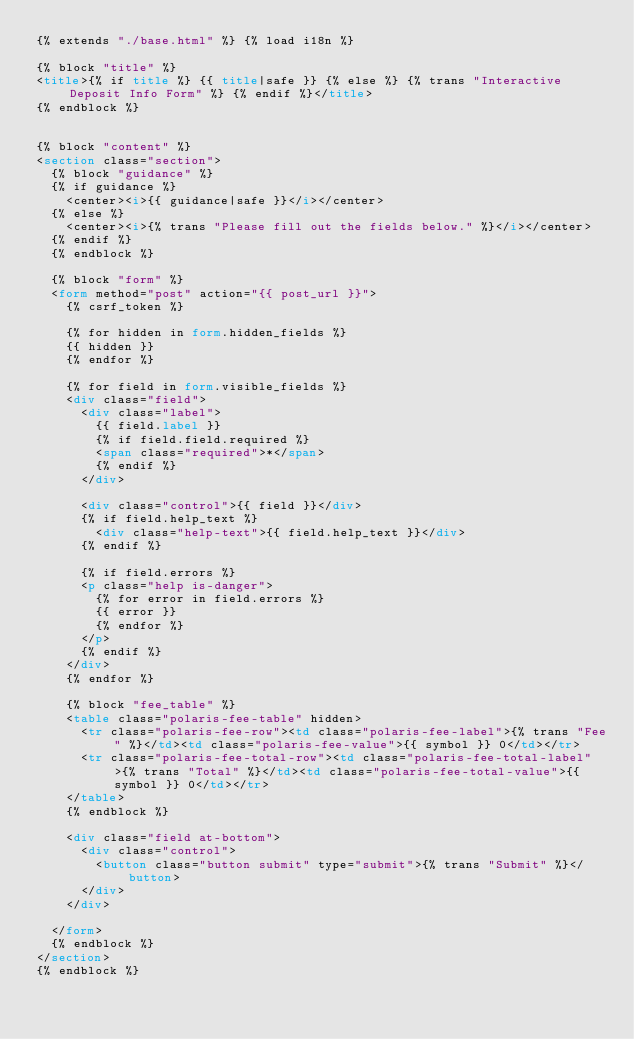<code> <loc_0><loc_0><loc_500><loc_500><_HTML_>{% extends "./base.html" %} {% load i18n %}

{% block "title" %}
<title>{% if title %} {{ title|safe }} {% else %} {% trans "Interactive Deposit Info Form" %} {% endif %}</title>
{% endblock %}


{% block "content" %}
<section class="section">
  {% block "guidance" %}
  {% if guidance %}
    <center><i>{{ guidance|safe }}</i></center>
  {% else %}
    <center><i>{% trans "Please fill out the fields below." %}</i></center>
  {% endif %}
  {% endblock %}

  {% block "form" %}
  <form method="post" action="{{ post_url }}">
    {% csrf_token %}

    {% for hidden in form.hidden_fields %}
    {{ hidden }}
    {% endfor %}

    {% for field in form.visible_fields %}
    <div class="field">
      <div class="label">
        {{ field.label }}
        {% if field.field.required %}
        <span class="required">*</span>
        {% endif %}
      </div>

      <div class="control">{{ field }}</div>
      {% if field.help_text %}
        <div class="help-text">{{ field.help_text }}</div>
      {% endif %}

      {% if field.errors %}
      <p class="help is-danger">
        {% for error in field.errors %}
        {{ error }}
        {% endfor %}
      </p>
      {% endif %}
    </div>
    {% endfor %}

    {% block "fee_table" %}
    <table class="polaris-fee-table" hidden>
      <tr class="polaris-fee-row"><td class="polaris-fee-label">{% trans "Fee" %}</td><td class="polaris-fee-value">{{ symbol }} 0</td></tr>
      <tr class="polaris-fee-total-row"><td class="polaris-fee-total-label">{% trans "Total" %}</td><td class="polaris-fee-total-value">{{ symbol }} 0</td></tr>
    </table>
    {% endblock %}

    <div class="field at-bottom">
      <div class="control">
        <button class="button submit" type="submit">{% trans "Submit" %}</button>
      </div>
    </div>

  </form>
  {% endblock %}
</section>
{% endblock %}
</code> 